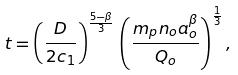Convert formula to latex. <formula><loc_0><loc_0><loc_500><loc_500>t = \left ( \frac { D } { 2 c _ { 1 } } \right ) ^ { \frac { 5 - \beta } { 3 } } \, \left ( \frac { m _ { p } n _ { o } a _ { o } ^ { \beta } } { Q _ { o } } \right ) ^ { \frac { 1 } { 3 } } ,</formula> 